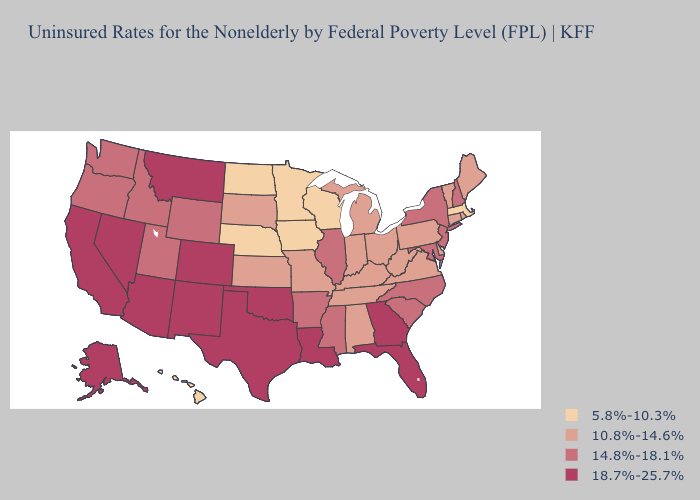Does the map have missing data?
Concise answer only. No. Name the states that have a value in the range 14.8%-18.1%?
Quick response, please. Arkansas, Idaho, Illinois, Maryland, Mississippi, New Hampshire, New Jersey, New York, North Carolina, Oregon, South Carolina, Utah, Washington, Wyoming. Name the states that have a value in the range 18.7%-25.7%?
Short answer required. Alaska, Arizona, California, Colorado, Florida, Georgia, Louisiana, Montana, Nevada, New Mexico, Oklahoma, Texas. Among the states that border New Jersey , does Pennsylvania have the lowest value?
Short answer required. Yes. What is the highest value in the MidWest ?
Give a very brief answer. 14.8%-18.1%. Name the states that have a value in the range 5.8%-10.3%?
Keep it brief. Hawaii, Iowa, Massachusetts, Minnesota, Nebraska, North Dakota, Wisconsin. Does the map have missing data?
Give a very brief answer. No. Among the states that border Pennsylvania , which have the lowest value?
Give a very brief answer. Delaware, Ohio, West Virginia. Name the states that have a value in the range 14.8%-18.1%?
Quick response, please. Arkansas, Idaho, Illinois, Maryland, Mississippi, New Hampshire, New Jersey, New York, North Carolina, Oregon, South Carolina, Utah, Washington, Wyoming. Name the states that have a value in the range 14.8%-18.1%?
Be succinct. Arkansas, Idaho, Illinois, Maryland, Mississippi, New Hampshire, New Jersey, New York, North Carolina, Oregon, South Carolina, Utah, Washington, Wyoming. What is the lowest value in states that border Georgia?
Be succinct. 10.8%-14.6%. Name the states that have a value in the range 10.8%-14.6%?
Quick response, please. Alabama, Connecticut, Delaware, Indiana, Kansas, Kentucky, Maine, Michigan, Missouri, Ohio, Pennsylvania, Rhode Island, South Dakota, Tennessee, Vermont, Virginia, West Virginia. Among the states that border Connecticut , which have the highest value?
Be succinct. New York. 